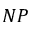<formula> <loc_0><loc_0><loc_500><loc_500>N P</formula> 